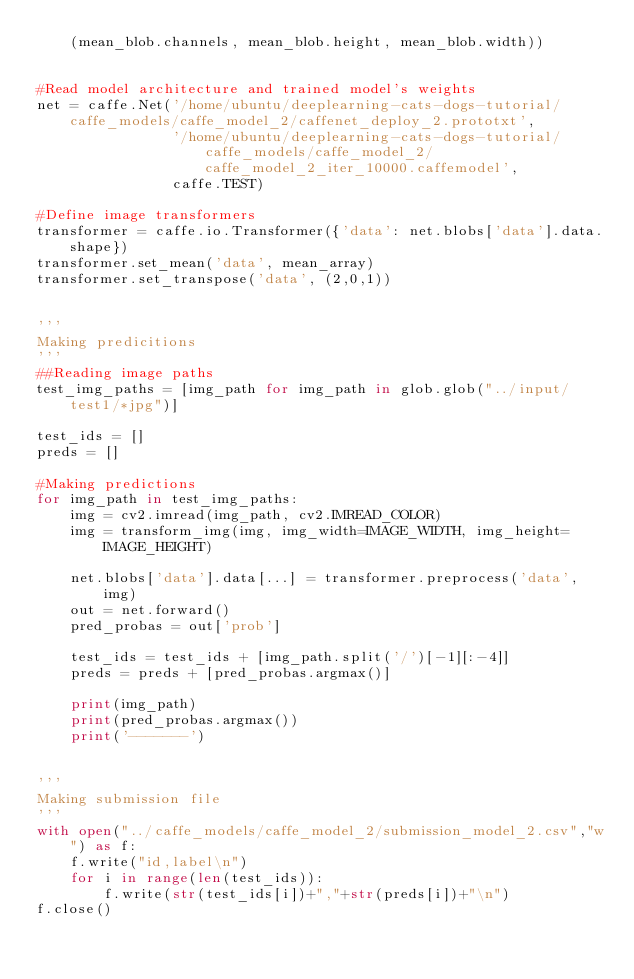Convert code to text. <code><loc_0><loc_0><loc_500><loc_500><_Python_>    (mean_blob.channels, mean_blob.height, mean_blob.width))


#Read model architecture and trained model's weights
net = caffe.Net('/home/ubuntu/deeplearning-cats-dogs-tutorial/caffe_models/caffe_model_2/caffenet_deploy_2.prototxt',
                '/home/ubuntu/deeplearning-cats-dogs-tutorial/caffe_models/caffe_model_2/caffe_model_2_iter_10000.caffemodel',
                caffe.TEST)

#Define image transformers
transformer = caffe.io.Transformer({'data': net.blobs['data'].data.shape})
transformer.set_mean('data', mean_array)
transformer.set_transpose('data', (2,0,1))


'''
Making predicitions
'''
##Reading image paths
test_img_paths = [img_path for img_path in glob.glob("../input/test1/*jpg")]

test_ids = []
preds = []

#Making predictions
for img_path in test_img_paths:
    img = cv2.imread(img_path, cv2.IMREAD_COLOR)
    img = transform_img(img, img_width=IMAGE_WIDTH, img_height=IMAGE_HEIGHT)
    
    net.blobs['data'].data[...] = transformer.preprocess('data', img)
    out = net.forward()
    pred_probas = out['prob']

    test_ids = test_ids + [img_path.split('/')[-1][:-4]]
    preds = preds + [pred_probas.argmax()]

    print(img_path)
    print(pred_probas.argmax())
    print('-------')


'''
Making submission file
'''
with open("../caffe_models/caffe_model_2/submission_model_2.csv","w") as f:
    f.write("id,label\n")
    for i in range(len(test_ids)):
        f.write(str(test_ids[i])+","+str(preds[i])+"\n")
f.close()
</code> 